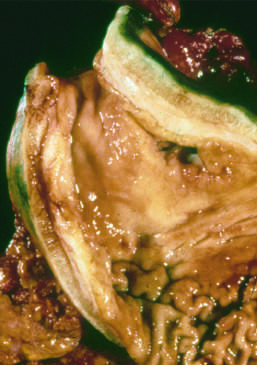s a binucleate reed-sternberg cell with large, inclusion-like nucleoli and abundant cytoplasm fold partially lost?
Answer the question using a single word or phrase. No 